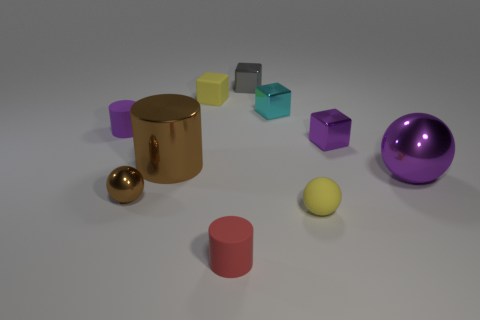Are there an equal number of yellow matte things behind the yellow rubber sphere and metallic cylinders?
Your response must be concise. Yes. What number of other objects are there of the same color as the small matte sphere?
Make the answer very short. 1. There is a sphere that is both left of the purple metal ball and on the right side of the big metal cylinder; what color is it?
Offer a terse response. Yellow. There is a purple shiny thing that is in front of the large brown object that is to the left of the metallic thing that is behind the yellow cube; what size is it?
Offer a very short reply. Large. How many things are either purple objects that are left of the large brown metal thing or tiny balls that are right of the gray object?
Your answer should be very brief. 2. What is the shape of the purple rubber thing?
Offer a very short reply. Cylinder. What number of other things are there of the same material as the small purple cube
Your answer should be very brief. 5. There is a purple shiny thing that is the same shape as the small gray metal thing; what is its size?
Your response must be concise. Small. The tiny purple thing to the left of the metal block that is in front of the matte cylinder behind the small red matte thing is made of what material?
Provide a succinct answer. Rubber. Is there a large metallic sphere?
Ensure brevity in your answer.  Yes. 